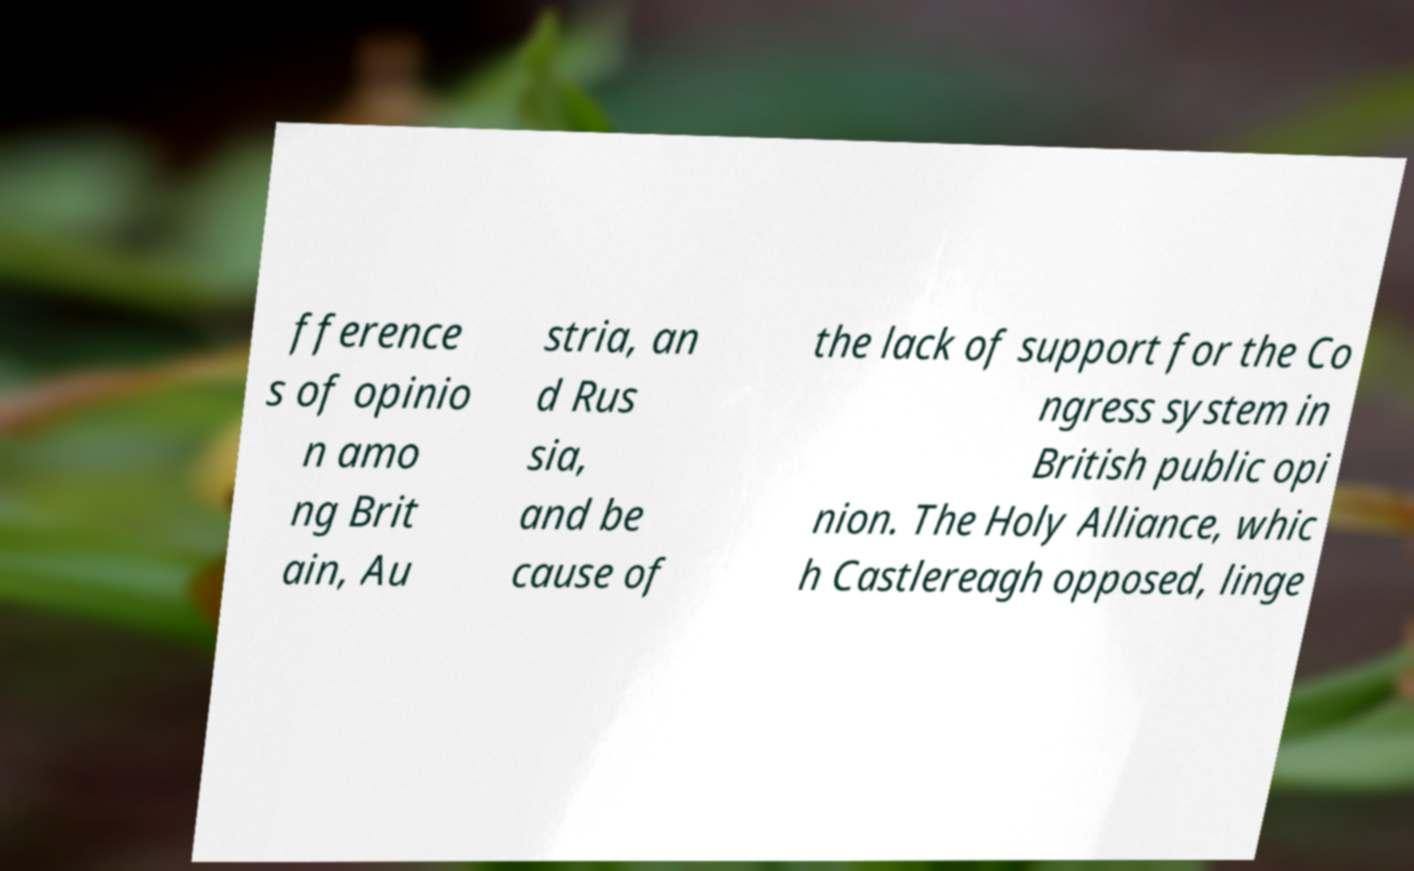Please read and relay the text visible in this image. What does it say? fference s of opinio n amo ng Brit ain, Au stria, an d Rus sia, and be cause of the lack of support for the Co ngress system in British public opi nion. The Holy Alliance, whic h Castlereagh opposed, linge 